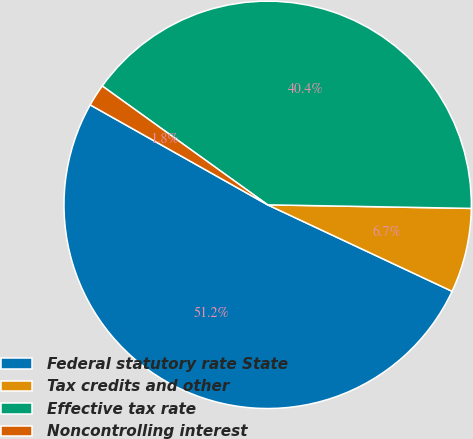Convert chart to OTSL. <chart><loc_0><loc_0><loc_500><loc_500><pie_chart><fcel>Federal statutory rate State<fcel>Tax credits and other<fcel>Effective tax rate<fcel>Noncontrolling interest<nl><fcel>51.18%<fcel>6.7%<fcel>40.36%<fcel>1.75%<nl></chart> 